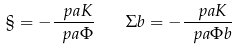<formula> <loc_0><loc_0><loc_500><loc_500>\S = - \frac { \ p a K } { \ p a \Phi } \quad \Sigma b = - \frac { \ p a K } { \ p a \Phi b }</formula> 